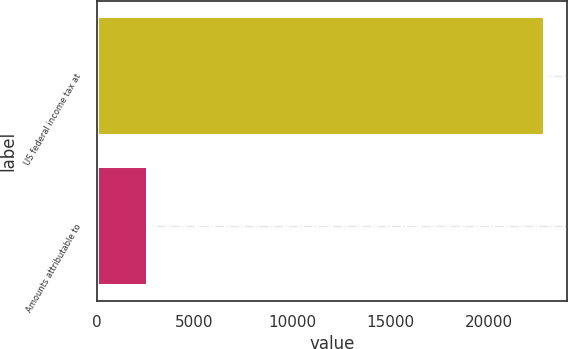<chart> <loc_0><loc_0><loc_500><loc_500><bar_chart><fcel>US federal income tax at<fcel>Amounts attributable to<nl><fcel>22877<fcel>2630<nl></chart> 